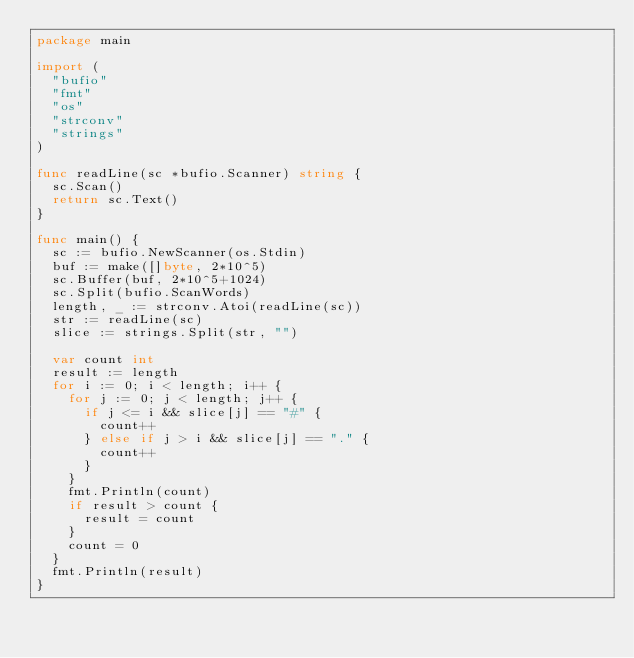Convert code to text. <code><loc_0><loc_0><loc_500><loc_500><_Go_>package main

import (
	"bufio"
	"fmt"
	"os"
	"strconv"
	"strings"
)

func readLine(sc *bufio.Scanner) string {
	sc.Scan()
	return sc.Text()
}

func main() {
	sc := bufio.NewScanner(os.Stdin)
	buf := make([]byte, 2*10^5)
	sc.Buffer(buf, 2*10^5+1024)
	sc.Split(bufio.ScanWords)
	length, _ := strconv.Atoi(readLine(sc))
	str := readLine(sc)
	slice := strings.Split(str, "")

	var count int
	result := length
	for i := 0; i < length; i++ {
		for j := 0; j < length; j++ {
			if j <= i && slice[j] == "#" {
				count++
			} else if j > i && slice[j] == "." {
				count++
			}
		}
		fmt.Println(count)
		if result > count {
			result = count
		}
		count = 0
	}
	fmt.Println(result)
}
</code> 